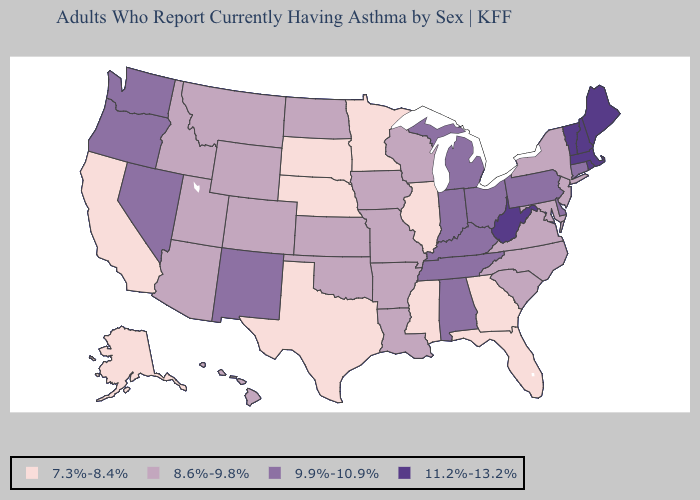Does Louisiana have the same value as North Dakota?
Quick response, please. Yes. Name the states that have a value in the range 8.6%-9.8%?
Quick response, please. Arizona, Arkansas, Colorado, Hawaii, Idaho, Iowa, Kansas, Louisiana, Maryland, Missouri, Montana, New Jersey, New York, North Carolina, North Dakota, Oklahoma, South Carolina, Utah, Virginia, Wisconsin, Wyoming. What is the value of Indiana?
Give a very brief answer. 9.9%-10.9%. Which states have the lowest value in the USA?
Answer briefly. Alaska, California, Florida, Georgia, Illinois, Minnesota, Mississippi, Nebraska, South Dakota, Texas. Does West Virginia have the highest value in the USA?
Keep it brief. Yes. What is the lowest value in the MidWest?
Keep it brief. 7.3%-8.4%. Does Pennsylvania have a higher value than Wyoming?
Give a very brief answer. Yes. Name the states that have a value in the range 9.9%-10.9%?
Concise answer only. Alabama, Connecticut, Delaware, Indiana, Kentucky, Michigan, Nevada, New Mexico, Ohio, Oregon, Pennsylvania, Tennessee, Washington. What is the value of Massachusetts?
Quick response, please. 11.2%-13.2%. Which states have the lowest value in the South?
Write a very short answer. Florida, Georgia, Mississippi, Texas. Name the states that have a value in the range 7.3%-8.4%?
Be succinct. Alaska, California, Florida, Georgia, Illinois, Minnesota, Mississippi, Nebraska, South Dakota, Texas. What is the lowest value in states that border Connecticut?
Answer briefly. 8.6%-9.8%. What is the value of Maryland?
Keep it brief. 8.6%-9.8%. What is the highest value in states that border Oklahoma?
Keep it brief. 9.9%-10.9%. What is the value of Missouri?
Be succinct. 8.6%-9.8%. 